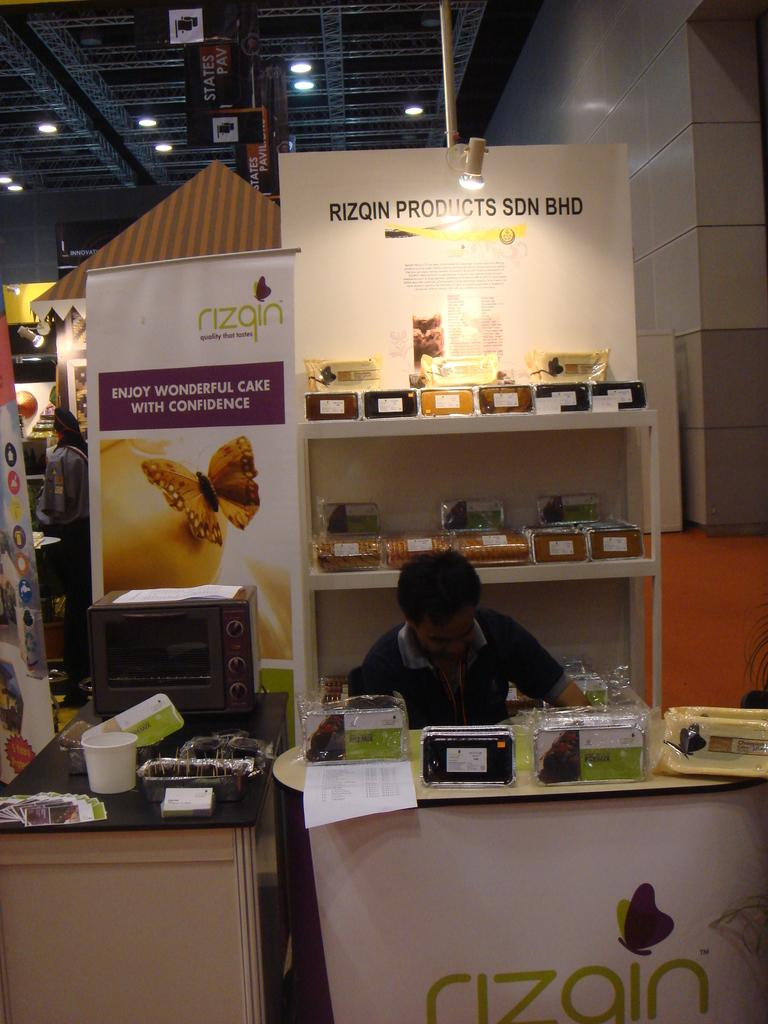<image>
Relay a brief, clear account of the picture shown. The stall recommends that you enjoy wonderful cake with confidence. 